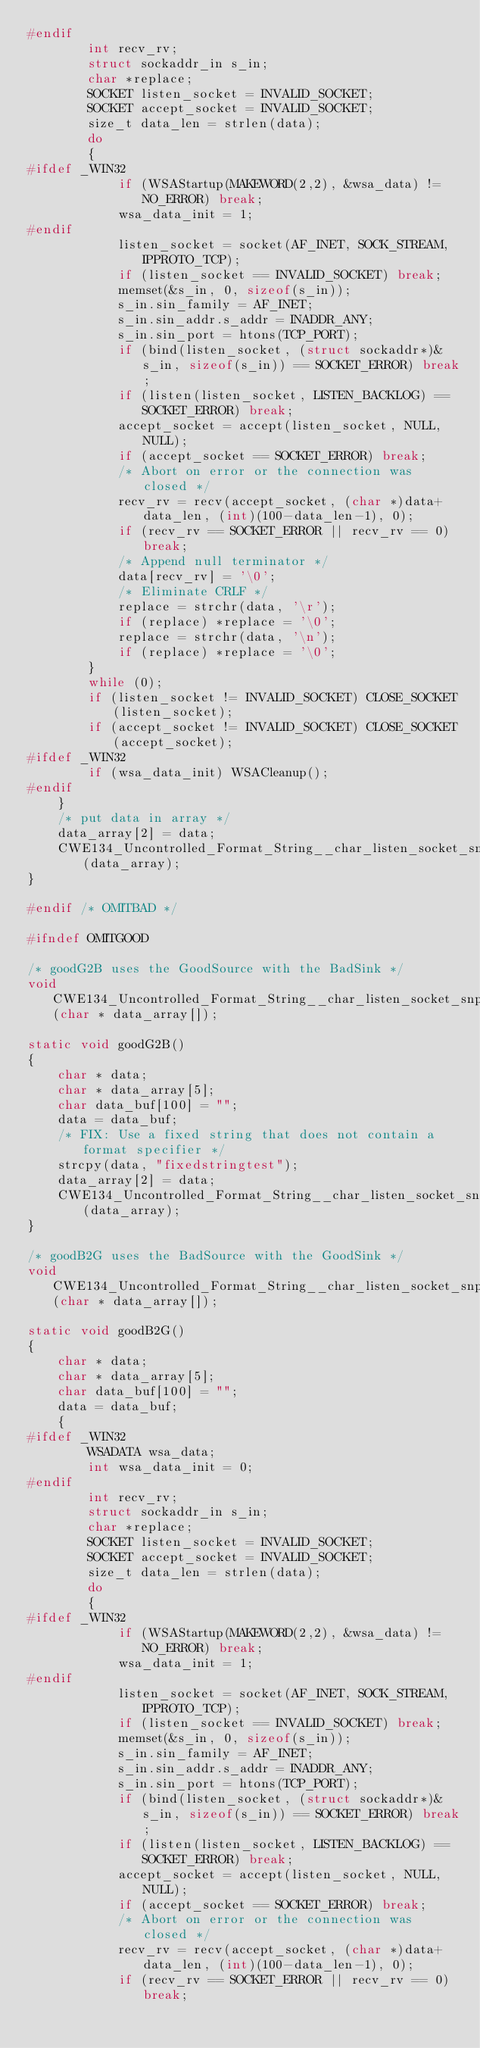<code> <loc_0><loc_0><loc_500><loc_500><_C_>#endif
        int recv_rv;
        struct sockaddr_in s_in;
        char *replace;
        SOCKET listen_socket = INVALID_SOCKET;
        SOCKET accept_socket = INVALID_SOCKET;
        size_t data_len = strlen(data);
        do
        {
#ifdef _WIN32
            if (WSAStartup(MAKEWORD(2,2), &wsa_data) != NO_ERROR) break;
            wsa_data_init = 1;
#endif
            listen_socket = socket(AF_INET, SOCK_STREAM, IPPROTO_TCP);
            if (listen_socket == INVALID_SOCKET) break;
            memset(&s_in, 0, sizeof(s_in));
            s_in.sin_family = AF_INET;
            s_in.sin_addr.s_addr = INADDR_ANY;
            s_in.sin_port = htons(TCP_PORT);
            if (bind(listen_socket, (struct sockaddr*)&s_in, sizeof(s_in)) == SOCKET_ERROR) break;
            if (listen(listen_socket, LISTEN_BACKLOG) == SOCKET_ERROR) break;
            accept_socket = accept(listen_socket, NULL, NULL);
            if (accept_socket == SOCKET_ERROR) break;
            /* Abort on error or the connection was closed */
            recv_rv = recv(accept_socket, (char *)data+data_len, (int)(100-data_len-1), 0);
            if (recv_rv == SOCKET_ERROR || recv_rv == 0) break;
            /* Append null terminator */
            data[recv_rv] = '\0';
            /* Eliminate CRLF */
            replace = strchr(data, '\r');
            if (replace) *replace = '\0';
            replace = strchr(data, '\n');
            if (replace) *replace = '\0';
        }
        while (0);
        if (listen_socket != INVALID_SOCKET) CLOSE_SOCKET(listen_socket);
        if (accept_socket != INVALID_SOCKET) CLOSE_SOCKET(accept_socket);
#ifdef _WIN32
        if (wsa_data_init) WSACleanup();
#endif
    }
    /* put data in array */
    data_array[2] = data;
    CWE134_Uncontrolled_Format_String__char_listen_socket_snprintf_66b_bad_sink(data_array);
}

#endif /* OMITBAD */

#ifndef OMITGOOD

/* goodG2B uses the GoodSource with the BadSink */
void CWE134_Uncontrolled_Format_String__char_listen_socket_snprintf_66b_goodG2B_sink(char * data_array[]);

static void goodG2B()
{
    char * data;
    char * data_array[5];
    char data_buf[100] = "";
    data = data_buf;
    /* FIX: Use a fixed string that does not contain a format specifier */
    strcpy(data, "fixedstringtest");
    data_array[2] = data;
    CWE134_Uncontrolled_Format_String__char_listen_socket_snprintf_66b_goodG2B_sink(data_array);
}

/* goodB2G uses the BadSource with the GoodSink */
void CWE134_Uncontrolled_Format_String__char_listen_socket_snprintf_66b_goodB2G_sink(char * data_array[]);

static void goodB2G()
{
    char * data;
    char * data_array[5];
    char data_buf[100] = "";
    data = data_buf;
    {
#ifdef _WIN32
        WSADATA wsa_data;
        int wsa_data_init = 0;
#endif
        int recv_rv;
        struct sockaddr_in s_in;
        char *replace;
        SOCKET listen_socket = INVALID_SOCKET;
        SOCKET accept_socket = INVALID_SOCKET;
        size_t data_len = strlen(data);
        do
        {
#ifdef _WIN32
            if (WSAStartup(MAKEWORD(2,2), &wsa_data) != NO_ERROR) break;
            wsa_data_init = 1;
#endif
            listen_socket = socket(AF_INET, SOCK_STREAM, IPPROTO_TCP);
            if (listen_socket == INVALID_SOCKET) break;
            memset(&s_in, 0, sizeof(s_in));
            s_in.sin_family = AF_INET;
            s_in.sin_addr.s_addr = INADDR_ANY;
            s_in.sin_port = htons(TCP_PORT);
            if (bind(listen_socket, (struct sockaddr*)&s_in, sizeof(s_in)) == SOCKET_ERROR) break;
            if (listen(listen_socket, LISTEN_BACKLOG) == SOCKET_ERROR) break;
            accept_socket = accept(listen_socket, NULL, NULL);
            if (accept_socket == SOCKET_ERROR) break;
            /* Abort on error or the connection was closed */
            recv_rv = recv(accept_socket, (char *)data+data_len, (int)(100-data_len-1), 0);
            if (recv_rv == SOCKET_ERROR || recv_rv == 0) break;</code> 